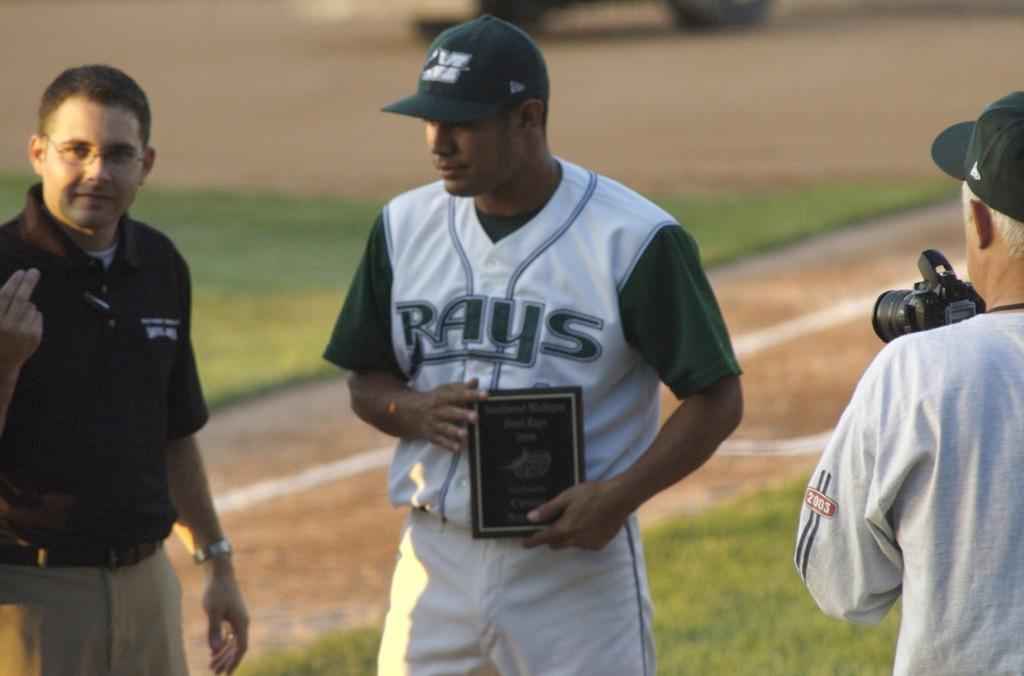Provide a one-sentence caption for the provided image. A Rays baseball player holds an award while standing on the field. 